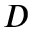<formula> <loc_0><loc_0><loc_500><loc_500>D</formula> 